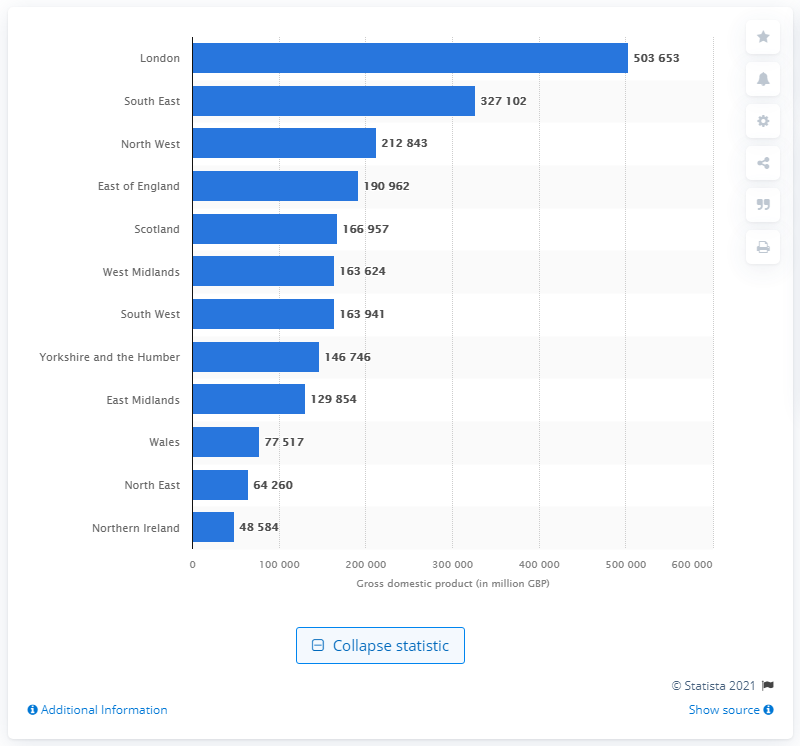Identify some key points in this picture. In 2019, London's gross domestic product was estimated to be 503,653 million U.S. dollars. The Gross Domestic Product (GDP) of South East England in 2019 was 327,102 million pounds. 